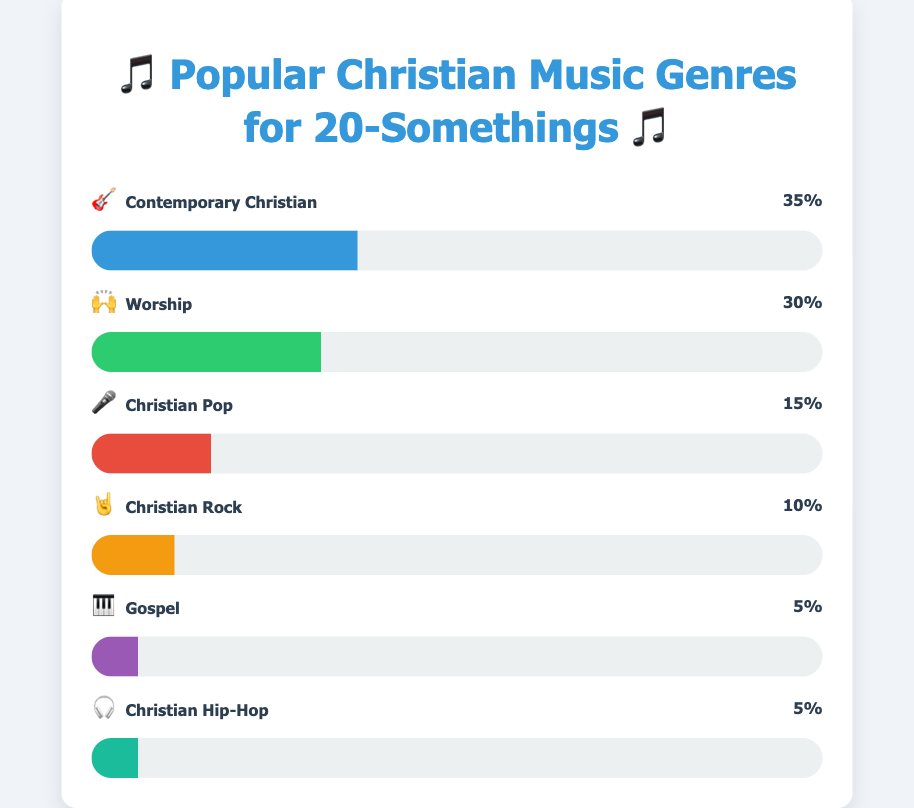What's the most popular Christian music genre among 20-somethings? The title indicates that the chart shows the popularity of Christian music genres among 20-somethings. The genre with the highest percentage is Contemporary Christian with 35%.
Answer: Contemporary Christian How much more popular is Contemporary Christian music compared to Gospel music? Contemporary Christian music has a percentage of 35%, while Gospel music has 5%. The difference is calculated as 35% - 5%.
Answer: 30% Which genre is equally popular to Gospel music in the chart? Both Gospel and Christian Hip-Hop music have the same percentage of 5%.
Answer: Christian Hip-Hop What is the combined percentage of Worship and Christian Pop music? Worship music is 30% and Christian Pop is 15%. The combined percentage is calculated by adding 30% and 15% together.
Answer: 45% Which genre represents 10% of the total? The chart shows that Christian Rock music has a percentage of 10%.
Answer: Christian Rock If you were to choose two genres that together make up less than 20%, which would they be? The genres with the smallest percentages are Gospel and Christian Hip-Hop, both at 5%. Adding these together gives 5% + 5% = 10%, which is less than 20%.
Answer: Gospel and Christian Hip-Hop What's the difference in popularity between Worship and Christian Rock music? Worship music is at 30% and Christian Rock is at 10%. The difference is calculated as 30% - 10%.
Answer: 20% If the percentage of Christian Pop music doubled, what would it be? The current percentage of Christian Pop music is 15%. If it doubled, it would be 15% * 2.
Answer: 30% How many genres have a percentage higher than 20%? The chart shows that Contemporary Christian (35%) and Worship (30%) are the only genres with percentages higher than 20%.
Answer: Two genres Which genre would you listen to if you like rock music? The chart indicates that Christian Rock music is a genre, represented by an emoji of a hand doing a rock sign (🤘).
Answer: Christian Rock 